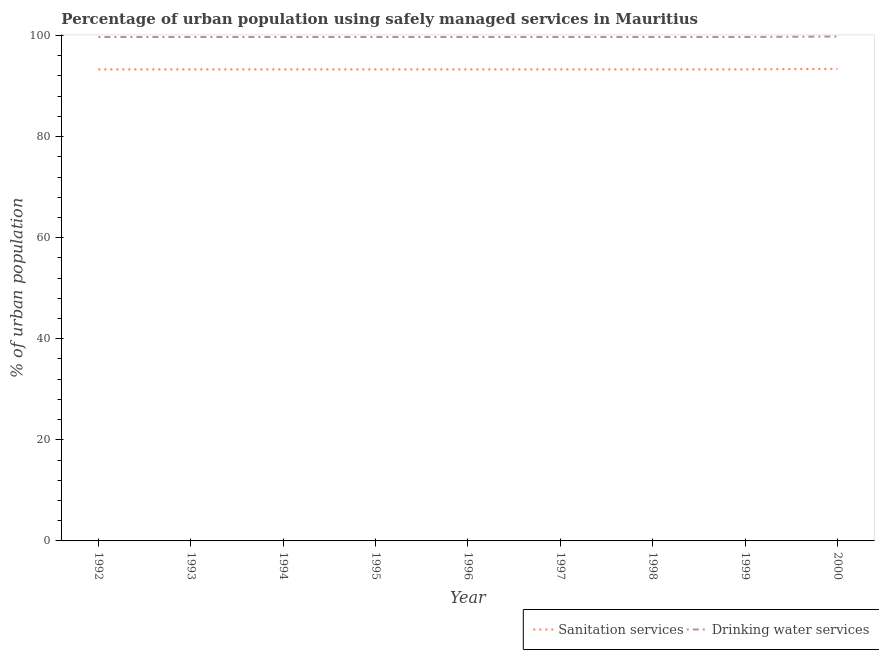Is the number of lines equal to the number of legend labels?
Your response must be concise. Yes. What is the percentage of urban population who used drinking water services in 1993?
Offer a very short reply. 99.7. Across all years, what is the maximum percentage of urban population who used sanitation services?
Offer a terse response. 93.4. Across all years, what is the minimum percentage of urban population who used sanitation services?
Offer a very short reply. 93.3. In which year was the percentage of urban population who used drinking water services maximum?
Your answer should be very brief. 2000. In which year was the percentage of urban population who used drinking water services minimum?
Provide a short and direct response. 1992. What is the total percentage of urban population who used drinking water services in the graph?
Make the answer very short. 897.4. What is the difference between the percentage of urban population who used drinking water services in 1998 and the percentage of urban population who used sanitation services in 1996?
Offer a terse response. 6.4. What is the average percentage of urban population who used sanitation services per year?
Make the answer very short. 93.31. In the year 1995, what is the difference between the percentage of urban population who used sanitation services and percentage of urban population who used drinking water services?
Your response must be concise. -6.4. What is the ratio of the percentage of urban population who used sanitation services in 1994 to that in 1996?
Provide a short and direct response. 1. Is the percentage of urban population who used sanitation services in 1992 less than that in 1998?
Provide a short and direct response. No. Is the difference between the percentage of urban population who used sanitation services in 1993 and 1995 greater than the difference between the percentage of urban population who used drinking water services in 1993 and 1995?
Your response must be concise. No. What is the difference between the highest and the second highest percentage of urban population who used drinking water services?
Offer a terse response. 0.1. What is the difference between the highest and the lowest percentage of urban population who used sanitation services?
Your answer should be compact. 0.1. Does the percentage of urban population who used drinking water services monotonically increase over the years?
Offer a very short reply. No. Is the percentage of urban population who used sanitation services strictly greater than the percentage of urban population who used drinking water services over the years?
Your response must be concise. No. Is the percentage of urban population who used drinking water services strictly less than the percentage of urban population who used sanitation services over the years?
Provide a short and direct response. No. How many lines are there?
Provide a short and direct response. 2. Does the graph contain any zero values?
Your response must be concise. No. Does the graph contain grids?
Provide a short and direct response. No. What is the title of the graph?
Give a very brief answer. Percentage of urban population using safely managed services in Mauritius. What is the label or title of the Y-axis?
Your response must be concise. % of urban population. What is the % of urban population in Sanitation services in 1992?
Provide a short and direct response. 93.3. What is the % of urban population in Drinking water services in 1992?
Keep it short and to the point. 99.7. What is the % of urban population of Sanitation services in 1993?
Give a very brief answer. 93.3. What is the % of urban population in Drinking water services in 1993?
Offer a terse response. 99.7. What is the % of urban population in Sanitation services in 1994?
Your answer should be compact. 93.3. What is the % of urban population of Drinking water services in 1994?
Give a very brief answer. 99.7. What is the % of urban population in Sanitation services in 1995?
Your answer should be very brief. 93.3. What is the % of urban population in Drinking water services in 1995?
Offer a terse response. 99.7. What is the % of urban population of Sanitation services in 1996?
Provide a short and direct response. 93.3. What is the % of urban population in Drinking water services in 1996?
Provide a succinct answer. 99.7. What is the % of urban population of Sanitation services in 1997?
Offer a terse response. 93.3. What is the % of urban population of Drinking water services in 1997?
Provide a short and direct response. 99.7. What is the % of urban population of Sanitation services in 1998?
Ensure brevity in your answer.  93.3. What is the % of urban population in Drinking water services in 1998?
Offer a terse response. 99.7. What is the % of urban population in Sanitation services in 1999?
Keep it short and to the point. 93.3. What is the % of urban population of Drinking water services in 1999?
Keep it short and to the point. 99.7. What is the % of urban population in Sanitation services in 2000?
Provide a short and direct response. 93.4. What is the % of urban population of Drinking water services in 2000?
Your response must be concise. 99.8. Across all years, what is the maximum % of urban population of Sanitation services?
Ensure brevity in your answer.  93.4. Across all years, what is the maximum % of urban population in Drinking water services?
Make the answer very short. 99.8. Across all years, what is the minimum % of urban population of Sanitation services?
Make the answer very short. 93.3. Across all years, what is the minimum % of urban population in Drinking water services?
Make the answer very short. 99.7. What is the total % of urban population in Sanitation services in the graph?
Give a very brief answer. 839.8. What is the total % of urban population of Drinking water services in the graph?
Offer a terse response. 897.4. What is the difference between the % of urban population in Drinking water services in 1992 and that in 1993?
Your answer should be compact. 0. What is the difference between the % of urban population in Sanitation services in 1992 and that in 1994?
Your answer should be very brief. 0. What is the difference between the % of urban population of Drinking water services in 1992 and that in 1994?
Offer a very short reply. 0. What is the difference between the % of urban population of Sanitation services in 1992 and that in 1995?
Ensure brevity in your answer.  0. What is the difference between the % of urban population of Drinking water services in 1992 and that in 1998?
Your answer should be very brief. 0. What is the difference between the % of urban population in Sanitation services in 1992 and that in 1999?
Provide a succinct answer. 0. What is the difference between the % of urban population of Drinking water services in 1992 and that in 1999?
Provide a succinct answer. 0. What is the difference between the % of urban population of Sanitation services in 1992 and that in 2000?
Your response must be concise. -0.1. What is the difference between the % of urban population in Sanitation services in 1993 and that in 1995?
Your response must be concise. 0. What is the difference between the % of urban population in Sanitation services in 1993 and that in 1996?
Provide a short and direct response. 0. What is the difference between the % of urban population in Drinking water services in 1993 and that in 1996?
Keep it short and to the point. 0. What is the difference between the % of urban population in Sanitation services in 1993 and that in 1998?
Provide a succinct answer. 0. What is the difference between the % of urban population in Drinking water services in 1993 and that in 1999?
Make the answer very short. 0. What is the difference between the % of urban population in Drinking water services in 1993 and that in 2000?
Provide a short and direct response. -0.1. What is the difference between the % of urban population of Sanitation services in 1994 and that in 1996?
Offer a terse response. 0. What is the difference between the % of urban population in Drinking water services in 1994 and that in 1996?
Provide a succinct answer. 0. What is the difference between the % of urban population in Sanitation services in 1994 and that in 1997?
Offer a terse response. 0. What is the difference between the % of urban population in Drinking water services in 1994 and that in 1998?
Provide a short and direct response. 0. What is the difference between the % of urban population in Sanitation services in 1994 and that in 1999?
Ensure brevity in your answer.  0. What is the difference between the % of urban population of Drinking water services in 1994 and that in 1999?
Your answer should be compact. 0. What is the difference between the % of urban population of Sanitation services in 1994 and that in 2000?
Your answer should be compact. -0.1. What is the difference between the % of urban population of Drinking water services in 1994 and that in 2000?
Give a very brief answer. -0.1. What is the difference between the % of urban population in Sanitation services in 1995 and that in 1998?
Ensure brevity in your answer.  0. What is the difference between the % of urban population in Drinking water services in 1995 and that in 1998?
Keep it short and to the point. 0. What is the difference between the % of urban population in Sanitation services in 1995 and that in 1999?
Your answer should be very brief. 0. What is the difference between the % of urban population of Drinking water services in 1995 and that in 1999?
Offer a terse response. 0. What is the difference between the % of urban population of Sanitation services in 1995 and that in 2000?
Your answer should be very brief. -0.1. What is the difference between the % of urban population in Sanitation services in 1996 and that in 1998?
Your answer should be very brief. 0. What is the difference between the % of urban population in Drinking water services in 1996 and that in 1999?
Provide a succinct answer. 0. What is the difference between the % of urban population in Drinking water services in 1996 and that in 2000?
Provide a succinct answer. -0.1. What is the difference between the % of urban population of Sanitation services in 1997 and that in 1998?
Make the answer very short. 0. What is the difference between the % of urban population in Sanitation services in 1997 and that in 1999?
Your answer should be compact. 0. What is the difference between the % of urban population in Drinking water services in 1997 and that in 1999?
Provide a short and direct response. 0. What is the difference between the % of urban population in Sanitation services in 1999 and that in 2000?
Your answer should be very brief. -0.1. What is the difference between the % of urban population in Sanitation services in 1992 and the % of urban population in Drinking water services in 1998?
Your answer should be compact. -6.4. What is the difference between the % of urban population in Sanitation services in 1992 and the % of urban population in Drinking water services in 1999?
Offer a very short reply. -6.4. What is the difference between the % of urban population in Sanitation services in 1993 and the % of urban population in Drinking water services in 1995?
Give a very brief answer. -6.4. What is the difference between the % of urban population in Sanitation services in 1993 and the % of urban population in Drinking water services in 1996?
Ensure brevity in your answer.  -6.4. What is the difference between the % of urban population in Sanitation services in 1993 and the % of urban population in Drinking water services in 1997?
Your response must be concise. -6.4. What is the difference between the % of urban population in Sanitation services in 1993 and the % of urban population in Drinking water services in 1999?
Make the answer very short. -6.4. What is the difference between the % of urban population in Sanitation services in 1994 and the % of urban population in Drinking water services in 1995?
Offer a very short reply. -6.4. What is the difference between the % of urban population of Sanitation services in 1994 and the % of urban population of Drinking water services in 1996?
Keep it short and to the point. -6.4. What is the difference between the % of urban population in Sanitation services in 1994 and the % of urban population in Drinking water services in 1998?
Your answer should be very brief. -6.4. What is the difference between the % of urban population in Sanitation services in 1995 and the % of urban population in Drinking water services in 1996?
Provide a succinct answer. -6.4. What is the difference between the % of urban population in Sanitation services in 1995 and the % of urban population in Drinking water services in 1997?
Provide a succinct answer. -6.4. What is the difference between the % of urban population in Sanitation services in 1995 and the % of urban population in Drinking water services in 1998?
Provide a succinct answer. -6.4. What is the difference between the % of urban population in Sanitation services in 1995 and the % of urban population in Drinking water services in 1999?
Your answer should be compact. -6.4. What is the difference between the % of urban population in Sanitation services in 1996 and the % of urban population in Drinking water services in 1998?
Provide a succinct answer. -6.4. What is the difference between the % of urban population in Sanitation services in 1996 and the % of urban population in Drinking water services in 2000?
Keep it short and to the point. -6.5. What is the difference between the % of urban population in Sanitation services in 1997 and the % of urban population in Drinking water services in 1998?
Ensure brevity in your answer.  -6.4. What is the difference between the % of urban population in Sanitation services in 1997 and the % of urban population in Drinking water services in 1999?
Your answer should be compact. -6.4. What is the difference between the % of urban population in Sanitation services in 1998 and the % of urban population in Drinking water services in 2000?
Your response must be concise. -6.5. What is the average % of urban population of Sanitation services per year?
Provide a short and direct response. 93.31. What is the average % of urban population in Drinking water services per year?
Your answer should be very brief. 99.71. In the year 1992, what is the difference between the % of urban population in Sanitation services and % of urban population in Drinking water services?
Your response must be concise. -6.4. In the year 1993, what is the difference between the % of urban population of Sanitation services and % of urban population of Drinking water services?
Provide a short and direct response. -6.4. In the year 1994, what is the difference between the % of urban population of Sanitation services and % of urban population of Drinking water services?
Offer a very short reply. -6.4. In the year 1995, what is the difference between the % of urban population of Sanitation services and % of urban population of Drinking water services?
Ensure brevity in your answer.  -6.4. In the year 1997, what is the difference between the % of urban population in Sanitation services and % of urban population in Drinking water services?
Ensure brevity in your answer.  -6.4. In the year 2000, what is the difference between the % of urban population of Sanitation services and % of urban population of Drinking water services?
Offer a terse response. -6.4. What is the ratio of the % of urban population in Sanitation services in 1992 to that in 1993?
Your response must be concise. 1. What is the ratio of the % of urban population of Drinking water services in 1992 to that in 1993?
Your answer should be very brief. 1. What is the ratio of the % of urban population of Sanitation services in 1992 to that in 1995?
Keep it short and to the point. 1. What is the ratio of the % of urban population of Drinking water services in 1992 to that in 1995?
Your answer should be very brief. 1. What is the ratio of the % of urban population of Sanitation services in 1992 to that in 1997?
Your response must be concise. 1. What is the ratio of the % of urban population in Sanitation services in 1992 to that in 1998?
Offer a terse response. 1. What is the ratio of the % of urban population of Drinking water services in 1992 to that in 1998?
Your response must be concise. 1. What is the ratio of the % of urban population of Sanitation services in 1992 to that in 1999?
Your answer should be compact. 1. What is the ratio of the % of urban population of Drinking water services in 1992 to that in 2000?
Make the answer very short. 1. What is the ratio of the % of urban population in Sanitation services in 1993 to that in 1994?
Your answer should be very brief. 1. What is the ratio of the % of urban population of Sanitation services in 1993 to that in 1996?
Provide a short and direct response. 1. What is the ratio of the % of urban population of Drinking water services in 1993 to that in 1996?
Keep it short and to the point. 1. What is the ratio of the % of urban population in Sanitation services in 1993 to that in 1997?
Provide a short and direct response. 1. What is the ratio of the % of urban population of Sanitation services in 1993 to that in 1999?
Your answer should be very brief. 1. What is the ratio of the % of urban population of Drinking water services in 1993 to that in 1999?
Your answer should be compact. 1. What is the ratio of the % of urban population in Sanitation services in 1993 to that in 2000?
Your response must be concise. 1. What is the ratio of the % of urban population in Sanitation services in 1994 to that in 1997?
Offer a very short reply. 1. What is the ratio of the % of urban population in Drinking water services in 1994 to that in 1997?
Make the answer very short. 1. What is the ratio of the % of urban population of Sanitation services in 1994 to that in 1998?
Keep it short and to the point. 1. What is the ratio of the % of urban population of Drinking water services in 1994 to that in 1998?
Give a very brief answer. 1. What is the ratio of the % of urban population of Sanitation services in 1994 to that in 1999?
Make the answer very short. 1. What is the ratio of the % of urban population of Drinking water services in 1994 to that in 1999?
Your answer should be very brief. 1. What is the ratio of the % of urban population in Sanitation services in 1995 to that in 1996?
Provide a short and direct response. 1. What is the ratio of the % of urban population of Sanitation services in 1995 to that in 1997?
Make the answer very short. 1. What is the ratio of the % of urban population of Sanitation services in 1995 to that in 1998?
Provide a succinct answer. 1. What is the ratio of the % of urban population of Sanitation services in 1995 to that in 1999?
Provide a short and direct response. 1. What is the ratio of the % of urban population of Sanitation services in 1995 to that in 2000?
Offer a terse response. 1. What is the ratio of the % of urban population of Sanitation services in 1996 to that in 1997?
Make the answer very short. 1. What is the ratio of the % of urban population in Drinking water services in 1996 to that in 1998?
Ensure brevity in your answer.  1. What is the ratio of the % of urban population in Sanitation services in 1996 to that in 2000?
Provide a short and direct response. 1. What is the ratio of the % of urban population of Drinking water services in 1997 to that in 1999?
Ensure brevity in your answer.  1. What is the ratio of the % of urban population in Drinking water services in 1997 to that in 2000?
Provide a succinct answer. 1. What is the ratio of the % of urban population of Drinking water services in 1998 to that in 2000?
Offer a very short reply. 1. What is the difference between the highest and the second highest % of urban population in Drinking water services?
Make the answer very short. 0.1. 